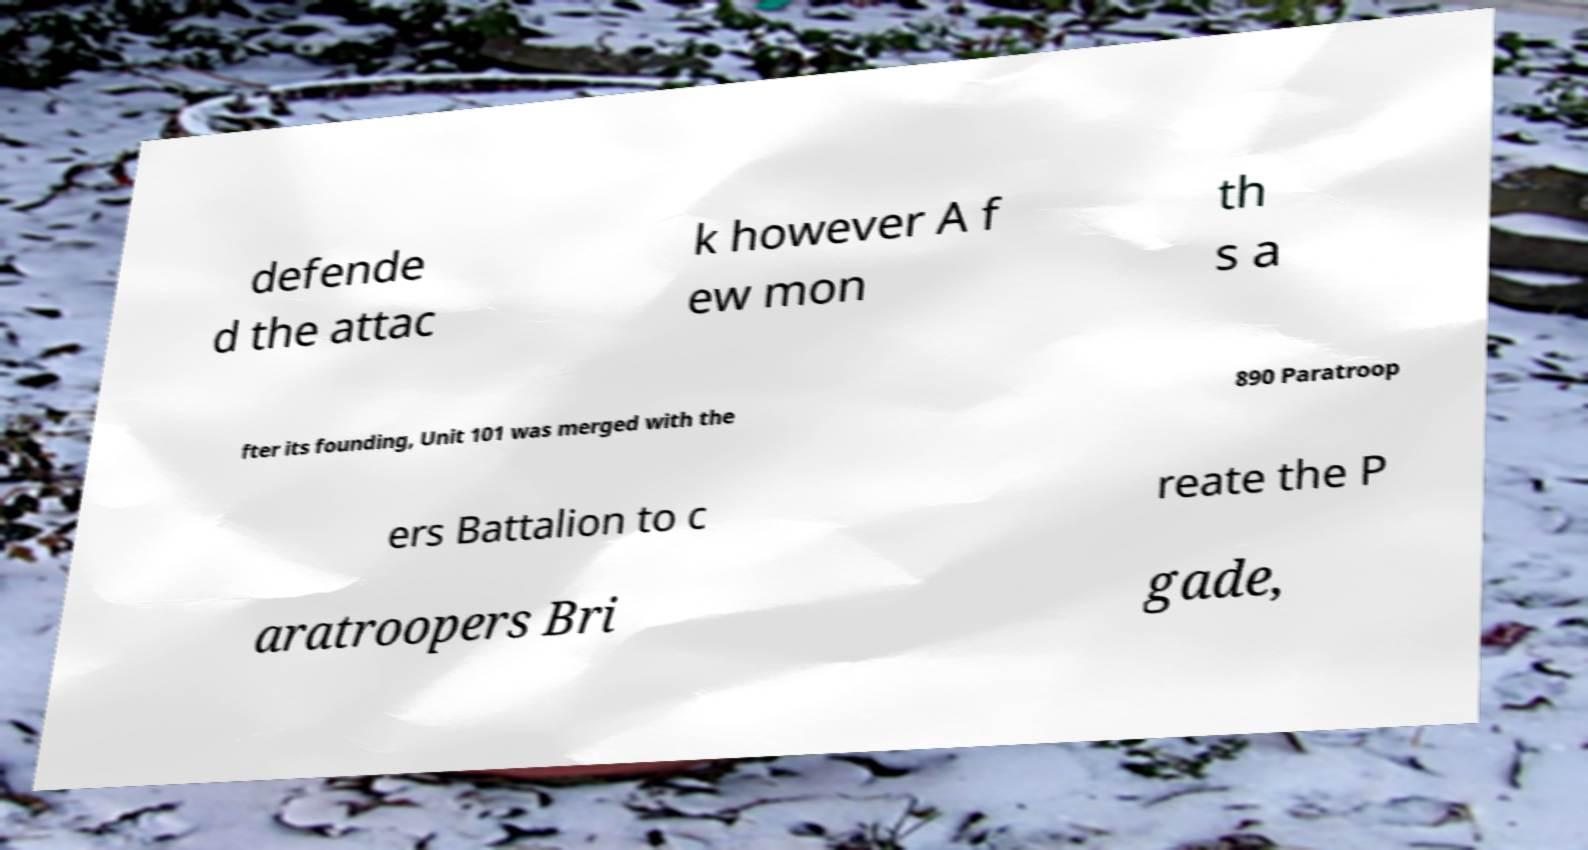There's text embedded in this image that I need extracted. Can you transcribe it verbatim? defende d the attac k however A f ew mon th s a fter its founding, Unit 101 was merged with the 890 Paratroop ers Battalion to c reate the P aratroopers Bri gade, 